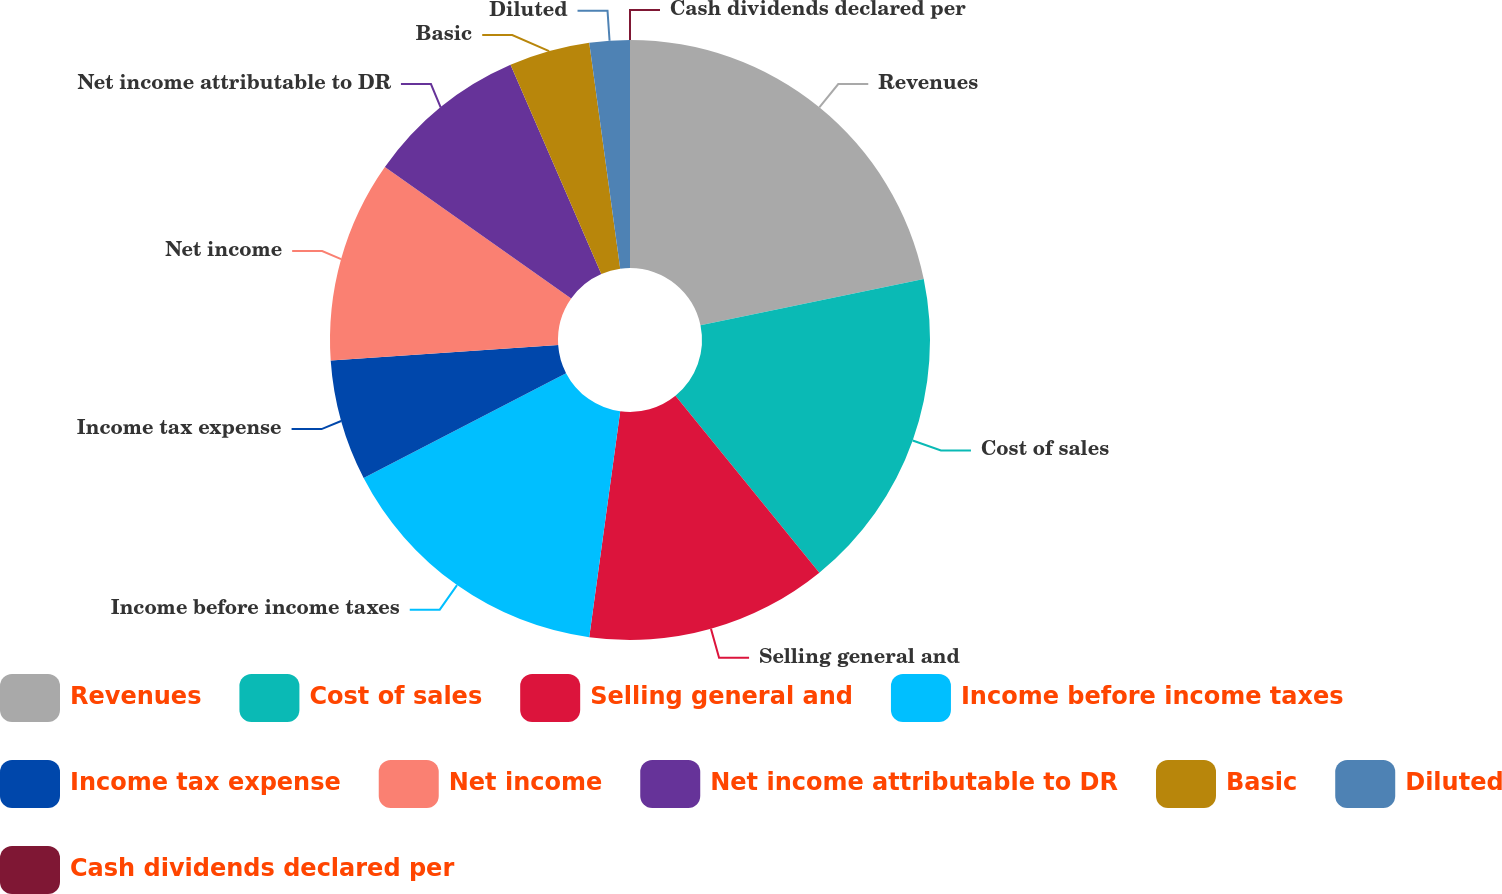Convert chart. <chart><loc_0><loc_0><loc_500><loc_500><pie_chart><fcel>Revenues<fcel>Cost of sales<fcel>Selling general and<fcel>Income before income taxes<fcel>Income tax expense<fcel>Net income<fcel>Net income attributable to DR<fcel>Basic<fcel>Diluted<fcel>Cash dividends declared per<nl><fcel>21.74%<fcel>17.39%<fcel>13.04%<fcel>15.22%<fcel>6.52%<fcel>10.87%<fcel>8.7%<fcel>4.35%<fcel>2.17%<fcel>0.0%<nl></chart> 